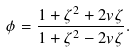<formula> <loc_0><loc_0><loc_500><loc_500>\phi = \frac { 1 + \zeta ^ { 2 } + 2 v \zeta } { 1 + \zeta ^ { 2 } - 2 v \zeta } .</formula> 